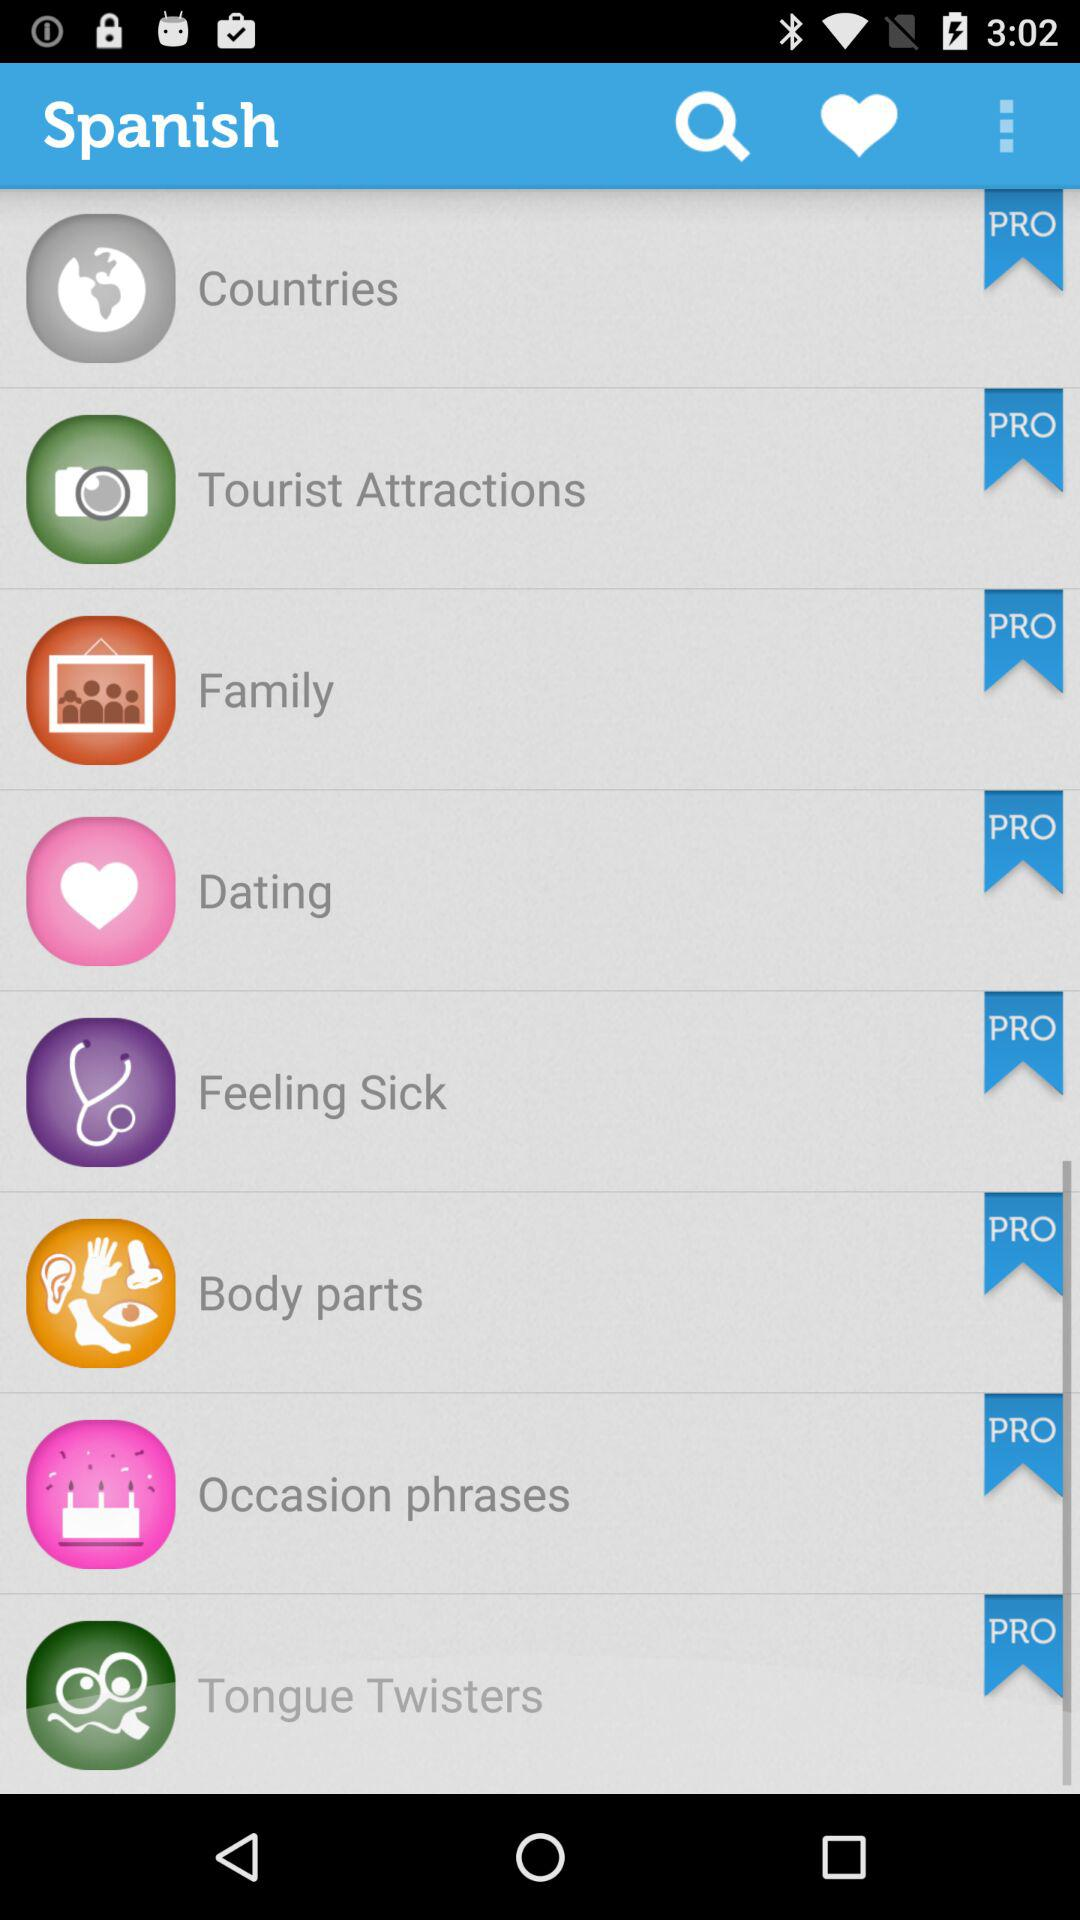What is the name of the application? The name of the application is "Spanish". 